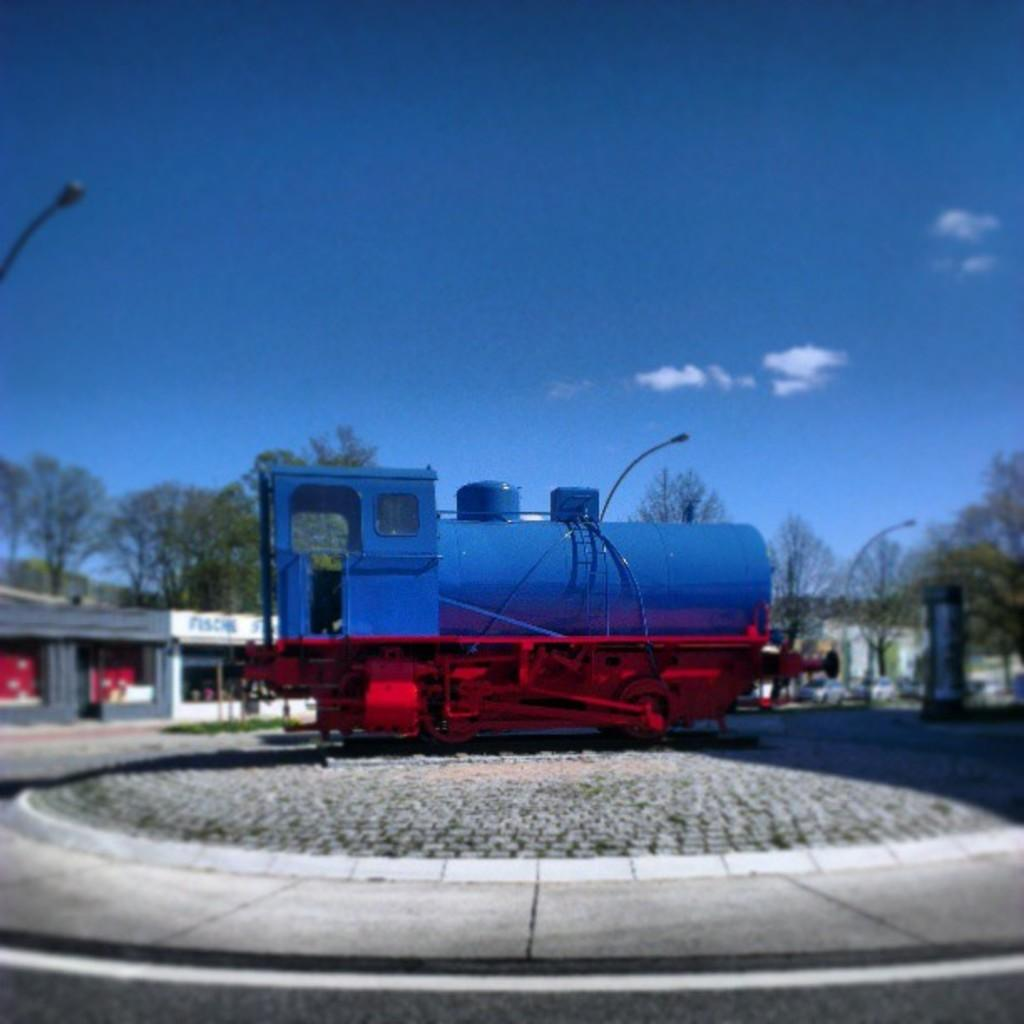What is the main subject in the foreground of the image? There is a train in the foreground of the image, but it is not a real train. What can be seen in the background of the image? There is a road, grass, buildings, trees, street poles, and the sky visible in the background of the image. What is the condition of the sky in the image? The sky is visible in the background of the image, and clouds are present in the sky. Can you tell me where the receipt is located in the image? There is no receipt present in the image. What type of creature is interacting with the train in the image? There is no creature present in the image; it is a model train. 